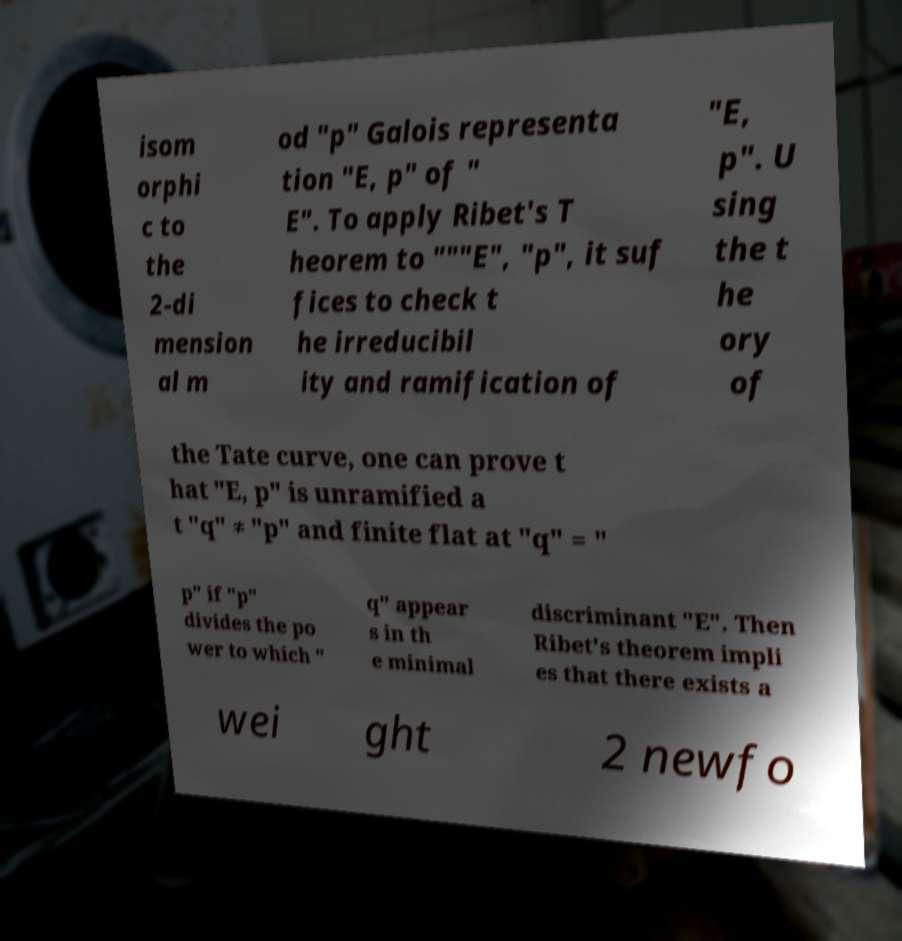I need the written content from this picture converted into text. Can you do that? isom orphi c to the 2-di mension al m od "p" Galois representa tion "E, p" of " E". To apply Ribet's T heorem to """E", "p", it suf fices to check t he irreducibil ity and ramification of "E, p". U sing the t he ory of the Tate curve, one can prove t hat "E, p" is unramified a t "q" ≠ "p" and finite flat at "q" = " p" if "p" divides the po wer to which " q" appear s in th e minimal discriminant "E". Then Ribet's theorem impli es that there exists a wei ght 2 newfo 